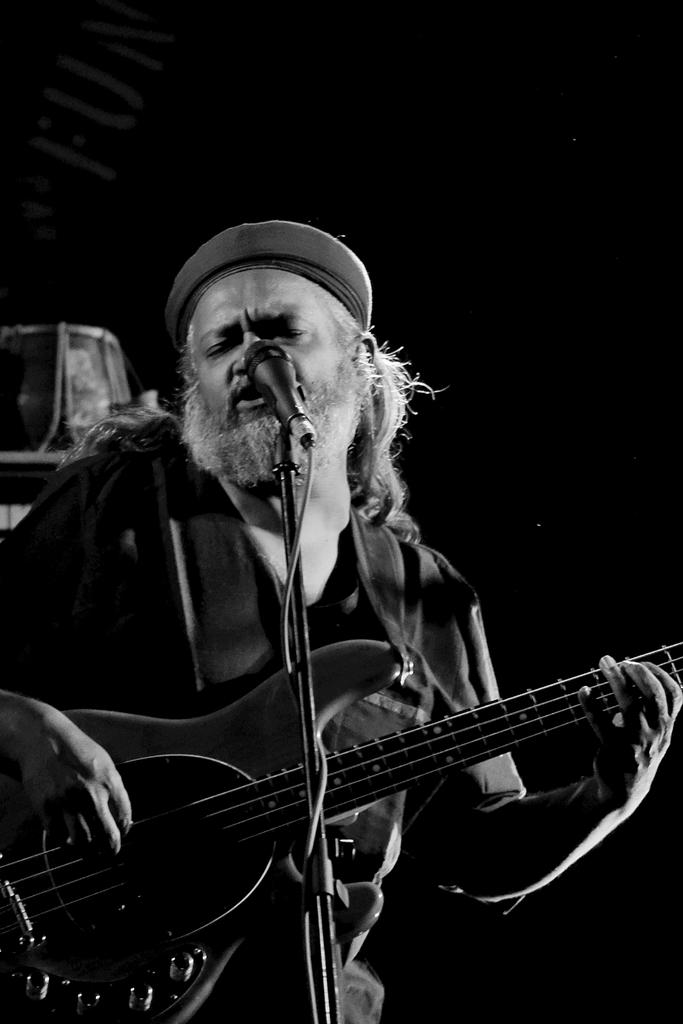Who is the main subject in the image? There is a man in the image. What is the man doing in the image? The man is standing, playing a guitar, and singing. What is the man using to amplify his voice? There is a microphone in front of the man. What other musical instrument is present in the image? There is a drum behind the man. What is the man's brother doing while he is playing the guitar? There is no information about the man's brother in the image, so we cannot answer this question. 